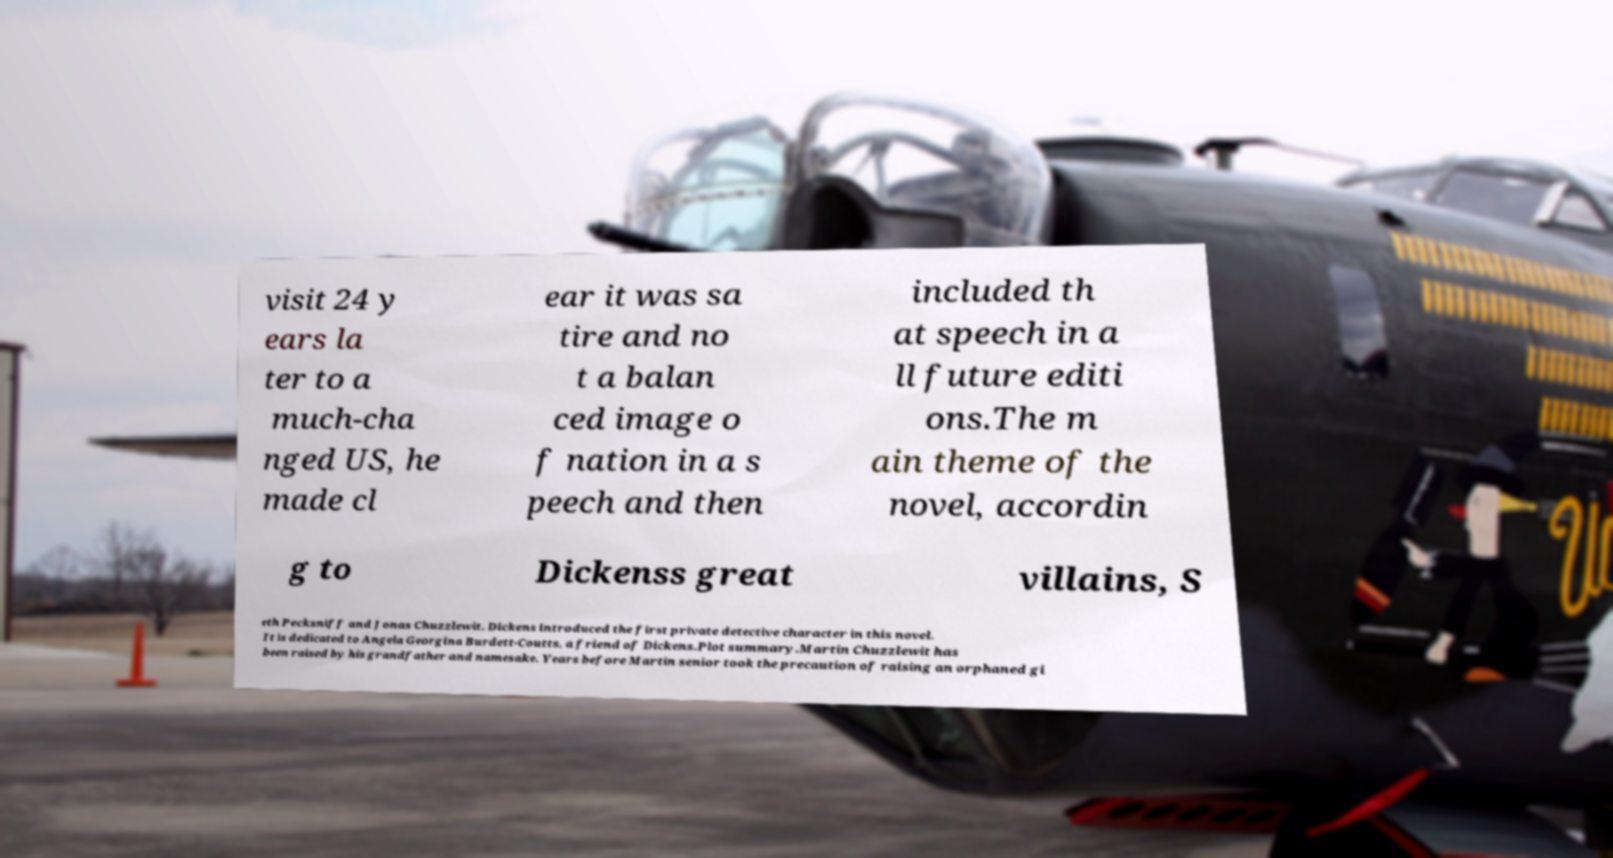Can you read and provide the text displayed in the image?This photo seems to have some interesting text. Can you extract and type it out for me? visit 24 y ears la ter to a much-cha nged US, he made cl ear it was sa tire and no t a balan ced image o f nation in a s peech and then included th at speech in a ll future editi ons.The m ain theme of the novel, accordin g to Dickenss great villains, S eth Pecksniff and Jonas Chuzzlewit. Dickens introduced the first private detective character in this novel. It is dedicated to Angela Georgina Burdett-Coutts, a friend of Dickens.Plot summary.Martin Chuzzlewit has been raised by his grandfather and namesake. Years before Martin senior took the precaution of raising an orphaned gi 